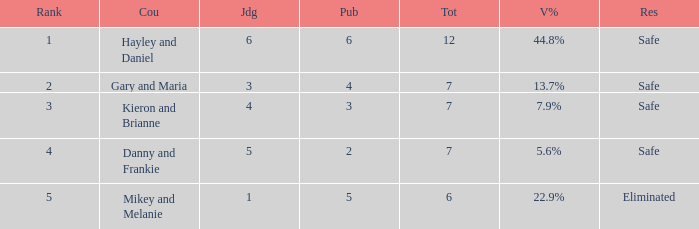What was the total number when the vote percentage was 44.8%? 1.0. 